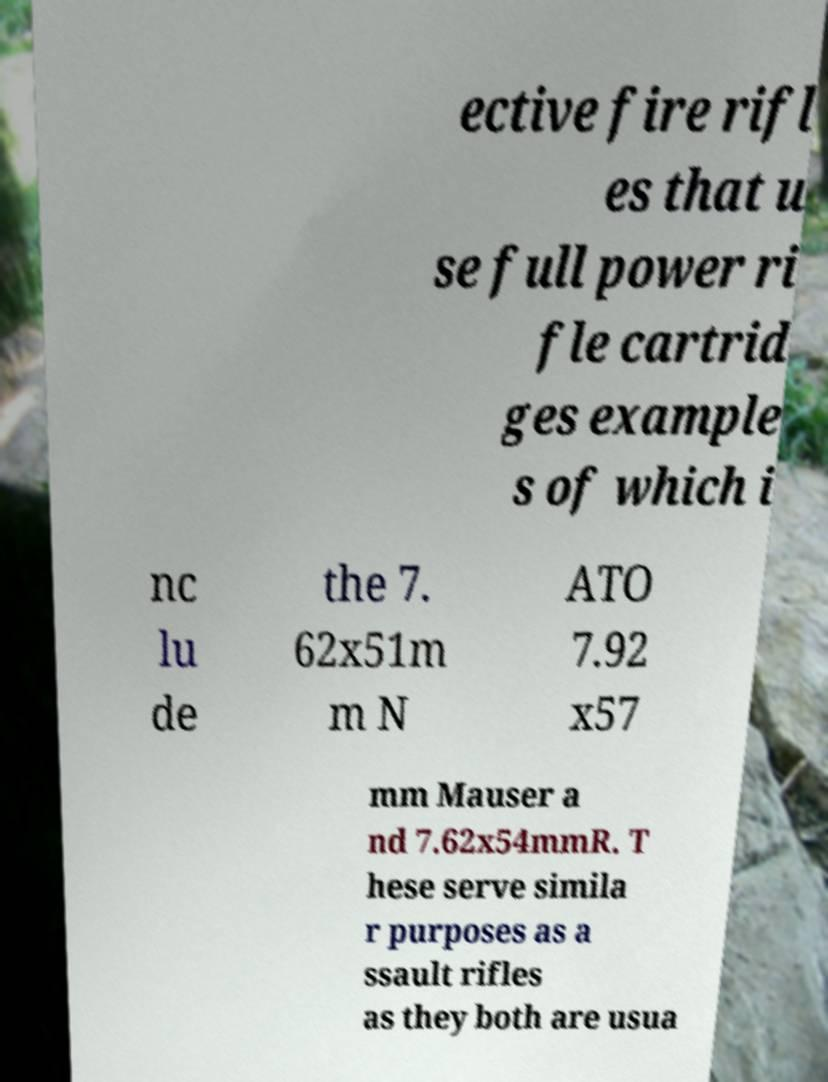Could you extract and type out the text from this image? ective fire rifl es that u se full power ri fle cartrid ges example s of which i nc lu de the 7. 62x51m m N ATO 7.92 x57 mm Mauser a nd 7.62x54mmR. T hese serve simila r purposes as a ssault rifles as they both are usua 